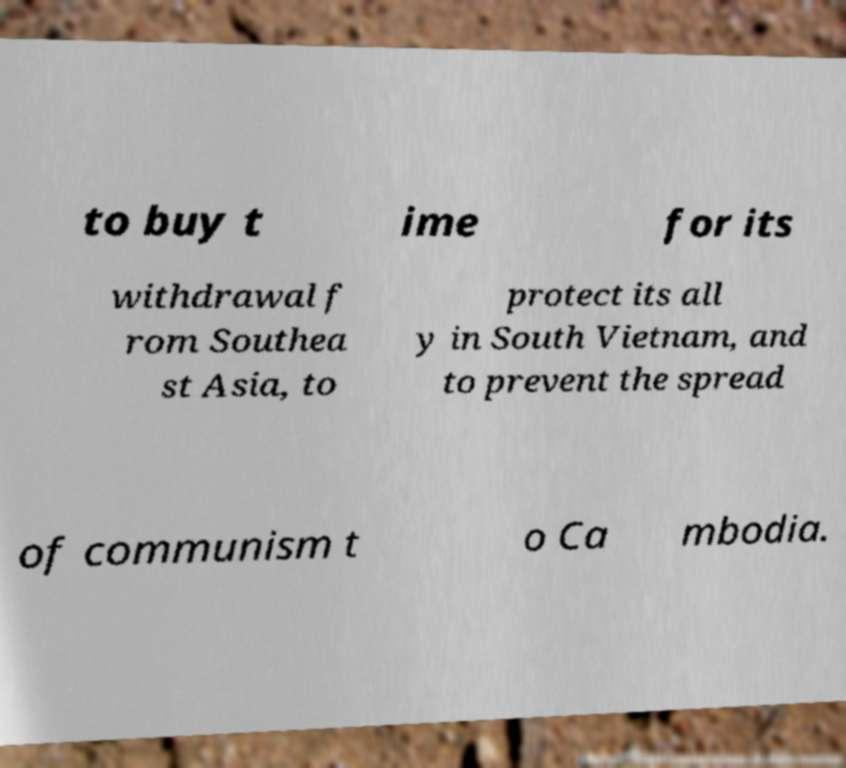Please read and relay the text visible in this image. What does it say? to buy t ime for its withdrawal f rom Southea st Asia, to protect its all y in South Vietnam, and to prevent the spread of communism t o Ca mbodia. 